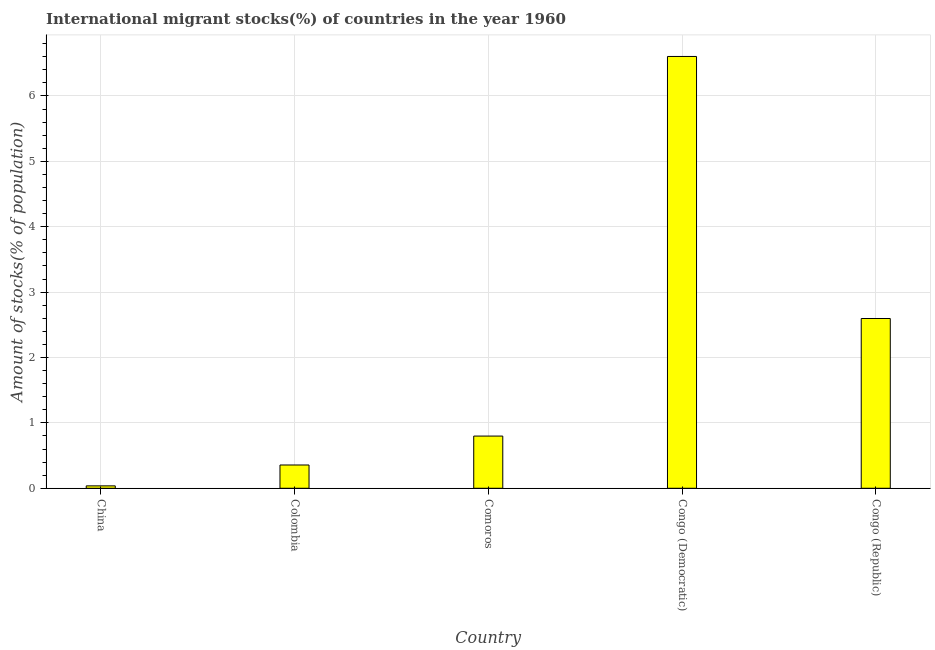What is the title of the graph?
Offer a very short reply. International migrant stocks(%) of countries in the year 1960. What is the label or title of the X-axis?
Make the answer very short. Country. What is the label or title of the Y-axis?
Your response must be concise. Amount of stocks(% of population). What is the number of international migrant stocks in Colombia?
Provide a succinct answer. 0.36. Across all countries, what is the maximum number of international migrant stocks?
Your answer should be very brief. 6.6. Across all countries, what is the minimum number of international migrant stocks?
Offer a terse response. 0.04. In which country was the number of international migrant stocks maximum?
Offer a terse response. Congo (Democratic). What is the sum of the number of international migrant stocks?
Ensure brevity in your answer.  10.39. What is the difference between the number of international migrant stocks in Congo (Democratic) and Congo (Republic)?
Keep it short and to the point. 4.01. What is the average number of international migrant stocks per country?
Your answer should be compact. 2.08. What is the median number of international migrant stocks?
Provide a succinct answer. 0.8. What is the ratio of the number of international migrant stocks in China to that in Congo (Republic)?
Offer a terse response. 0.01. Is the number of international migrant stocks in Congo (Democratic) less than that in Congo (Republic)?
Your response must be concise. No. Is the difference between the number of international migrant stocks in China and Comoros greater than the difference between any two countries?
Your response must be concise. No. What is the difference between the highest and the second highest number of international migrant stocks?
Ensure brevity in your answer.  4.01. Is the sum of the number of international migrant stocks in China and Colombia greater than the maximum number of international migrant stocks across all countries?
Offer a terse response. No. What is the difference between the highest and the lowest number of international migrant stocks?
Keep it short and to the point. 6.57. Are the values on the major ticks of Y-axis written in scientific E-notation?
Give a very brief answer. No. What is the Amount of stocks(% of population) in China?
Ensure brevity in your answer.  0.04. What is the Amount of stocks(% of population) of Colombia?
Make the answer very short. 0.36. What is the Amount of stocks(% of population) of Comoros?
Offer a very short reply. 0.8. What is the Amount of stocks(% of population) in Congo (Democratic)?
Your response must be concise. 6.6. What is the Amount of stocks(% of population) of Congo (Republic)?
Make the answer very short. 2.6. What is the difference between the Amount of stocks(% of population) in China and Colombia?
Keep it short and to the point. -0.32. What is the difference between the Amount of stocks(% of population) in China and Comoros?
Keep it short and to the point. -0.76. What is the difference between the Amount of stocks(% of population) in China and Congo (Democratic)?
Ensure brevity in your answer.  -6.57. What is the difference between the Amount of stocks(% of population) in China and Congo (Republic)?
Keep it short and to the point. -2.56. What is the difference between the Amount of stocks(% of population) in Colombia and Comoros?
Offer a very short reply. -0.44. What is the difference between the Amount of stocks(% of population) in Colombia and Congo (Democratic)?
Your answer should be compact. -6.25. What is the difference between the Amount of stocks(% of population) in Colombia and Congo (Republic)?
Keep it short and to the point. -2.24. What is the difference between the Amount of stocks(% of population) in Comoros and Congo (Democratic)?
Keep it short and to the point. -5.81. What is the difference between the Amount of stocks(% of population) in Comoros and Congo (Republic)?
Your response must be concise. -1.8. What is the difference between the Amount of stocks(% of population) in Congo (Democratic) and Congo (Republic)?
Make the answer very short. 4.01. What is the ratio of the Amount of stocks(% of population) in China to that in Colombia?
Your answer should be compact. 0.1. What is the ratio of the Amount of stocks(% of population) in China to that in Comoros?
Your answer should be compact. 0.05. What is the ratio of the Amount of stocks(% of population) in China to that in Congo (Democratic)?
Provide a short and direct response. 0.01. What is the ratio of the Amount of stocks(% of population) in China to that in Congo (Republic)?
Offer a terse response. 0.01. What is the ratio of the Amount of stocks(% of population) in Colombia to that in Comoros?
Provide a succinct answer. 0.45. What is the ratio of the Amount of stocks(% of population) in Colombia to that in Congo (Democratic)?
Your response must be concise. 0.05. What is the ratio of the Amount of stocks(% of population) in Colombia to that in Congo (Republic)?
Your answer should be very brief. 0.14. What is the ratio of the Amount of stocks(% of population) in Comoros to that in Congo (Democratic)?
Provide a short and direct response. 0.12. What is the ratio of the Amount of stocks(% of population) in Comoros to that in Congo (Republic)?
Your answer should be compact. 0.31. What is the ratio of the Amount of stocks(% of population) in Congo (Democratic) to that in Congo (Republic)?
Your answer should be very brief. 2.54. 